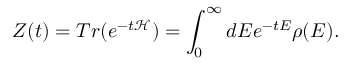Convert formula to latex. <formula><loc_0><loc_0><loc_500><loc_500>Z ( t ) = T r ( e ^ { - t \mathcal { H } } ) = \int _ { 0 } ^ { \infty } d E e ^ { - t E } \rho ( E ) .</formula> 